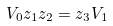Convert formula to latex. <formula><loc_0><loc_0><loc_500><loc_500>V _ { 0 } z _ { 1 } z _ { 2 } = z _ { 3 } V _ { 1 }</formula> 